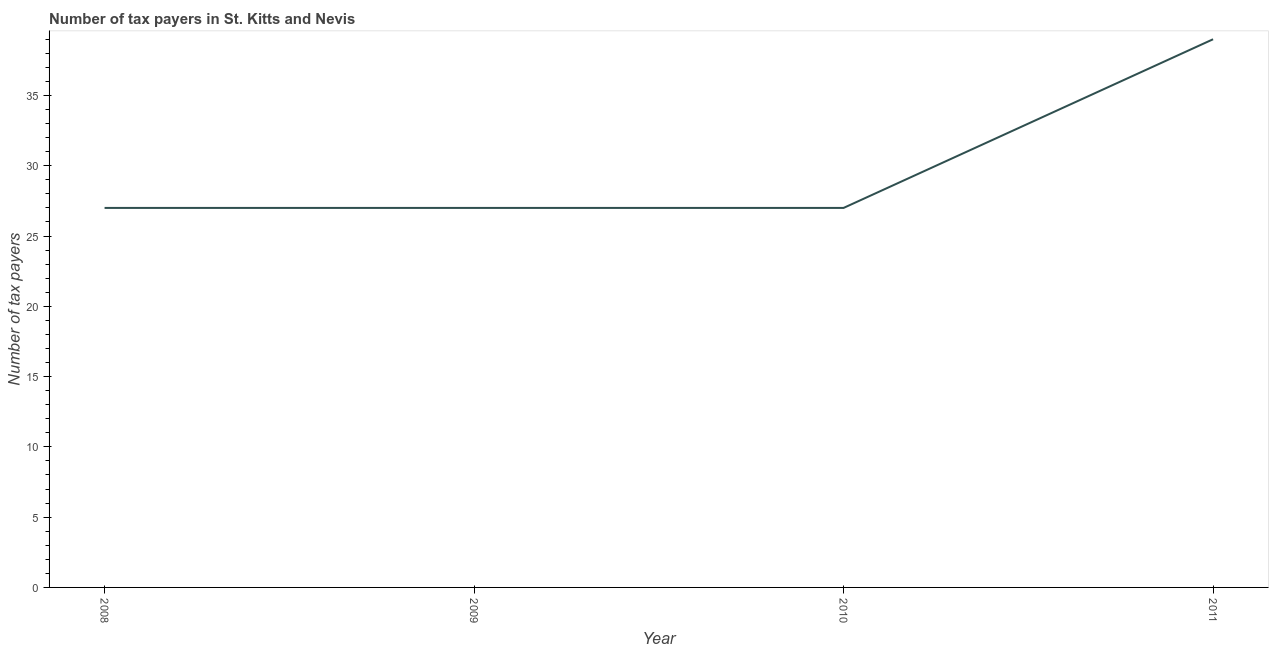What is the number of tax payers in 2008?
Provide a short and direct response. 27. Across all years, what is the maximum number of tax payers?
Make the answer very short. 39. Across all years, what is the minimum number of tax payers?
Provide a short and direct response. 27. In which year was the number of tax payers minimum?
Provide a succinct answer. 2008. What is the sum of the number of tax payers?
Provide a short and direct response. 120. What is the difference between the number of tax payers in 2010 and 2011?
Offer a terse response. -12. What is the median number of tax payers?
Keep it short and to the point. 27. In how many years, is the number of tax payers greater than 34 ?
Your answer should be very brief. 1. What is the difference between the highest and the second highest number of tax payers?
Your answer should be very brief. 12. What is the difference between the highest and the lowest number of tax payers?
Offer a very short reply. 12. Does the number of tax payers monotonically increase over the years?
Offer a very short reply. No. How many lines are there?
Your response must be concise. 1. How many years are there in the graph?
Your response must be concise. 4. Are the values on the major ticks of Y-axis written in scientific E-notation?
Make the answer very short. No. Does the graph contain any zero values?
Offer a terse response. No. Does the graph contain grids?
Your answer should be very brief. No. What is the title of the graph?
Make the answer very short. Number of tax payers in St. Kitts and Nevis. What is the label or title of the Y-axis?
Your response must be concise. Number of tax payers. What is the Number of tax payers of 2008?
Your answer should be compact. 27. What is the Number of tax payers of 2009?
Offer a terse response. 27. What is the Number of tax payers in 2011?
Provide a succinct answer. 39. What is the difference between the Number of tax payers in 2008 and 2010?
Your response must be concise. 0. What is the difference between the Number of tax payers in 2009 and 2010?
Ensure brevity in your answer.  0. What is the difference between the Number of tax payers in 2010 and 2011?
Offer a terse response. -12. What is the ratio of the Number of tax payers in 2008 to that in 2011?
Keep it short and to the point. 0.69. What is the ratio of the Number of tax payers in 2009 to that in 2011?
Your answer should be very brief. 0.69. What is the ratio of the Number of tax payers in 2010 to that in 2011?
Your answer should be compact. 0.69. 